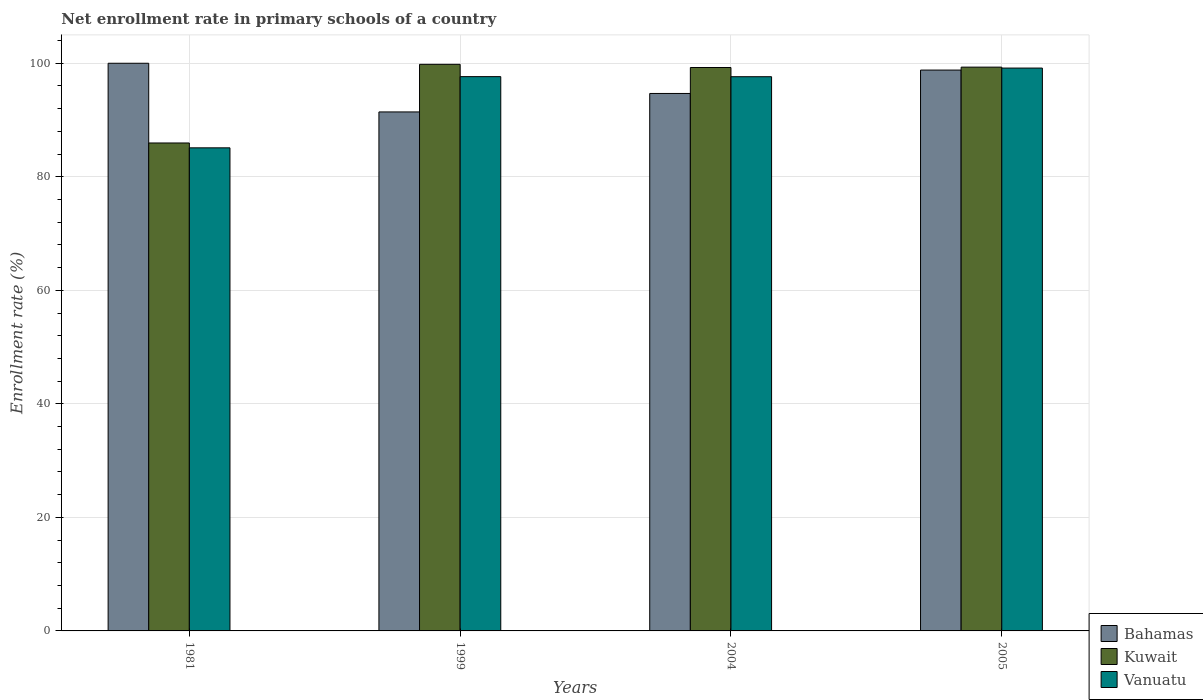How many groups of bars are there?
Provide a short and direct response. 4. Are the number of bars per tick equal to the number of legend labels?
Your answer should be very brief. Yes. Are the number of bars on each tick of the X-axis equal?
Your answer should be compact. Yes. What is the enrollment rate in primary schools in Bahamas in 1999?
Keep it short and to the point. 91.43. Across all years, what is the maximum enrollment rate in primary schools in Bahamas?
Provide a short and direct response. 100. Across all years, what is the minimum enrollment rate in primary schools in Bahamas?
Make the answer very short. 91.43. In which year was the enrollment rate in primary schools in Vanuatu minimum?
Your answer should be compact. 1981. What is the total enrollment rate in primary schools in Vanuatu in the graph?
Your response must be concise. 379.52. What is the difference between the enrollment rate in primary schools in Kuwait in 1999 and that in 2005?
Your answer should be compact. 0.49. What is the difference between the enrollment rate in primary schools in Bahamas in 1981 and the enrollment rate in primary schools in Vanuatu in 2004?
Your response must be concise. 2.37. What is the average enrollment rate in primary schools in Bahamas per year?
Your response must be concise. 96.23. In the year 2004, what is the difference between the enrollment rate in primary schools in Vanuatu and enrollment rate in primary schools in Bahamas?
Your answer should be very brief. 2.95. What is the ratio of the enrollment rate in primary schools in Kuwait in 1999 to that in 2004?
Your answer should be compact. 1.01. Is the enrollment rate in primary schools in Kuwait in 1981 less than that in 2005?
Keep it short and to the point. Yes. Is the difference between the enrollment rate in primary schools in Vanuatu in 1999 and 2005 greater than the difference between the enrollment rate in primary schools in Bahamas in 1999 and 2005?
Make the answer very short. Yes. What is the difference between the highest and the second highest enrollment rate in primary schools in Vanuatu?
Make the answer very short. 1.51. What is the difference between the highest and the lowest enrollment rate in primary schools in Bahamas?
Provide a succinct answer. 8.57. Is the sum of the enrollment rate in primary schools in Kuwait in 1999 and 2005 greater than the maximum enrollment rate in primary schools in Vanuatu across all years?
Provide a short and direct response. Yes. What does the 1st bar from the left in 1999 represents?
Offer a very short reply. Bahamas. What does the 3rd bar from the right in 2005 represents?
Provide a succinct answer. Bahamas. Is it the case that in every year, the sum of the enrollment rate in primary schools in Kuwait and enrollment rate in primary schools in Bahamas is greater than the enrollment rate in primary schools in Vanuatu?
Give a very brief answer. Yes. How many bars are there?
Provide a short and direct response. 12. Are all the bars in the graph horizontal?
Make the answer very short. No. What is the difference between two consecutive major ticks on the Y-axis?
Keep it short and to the point. 20. Are the values on the major ticks of Y-axis written in scientific E-notation?
Give a very brief answer. No. How many legend labels are there?
Give a very brief answer. 3. What is the title of the graph?
Your response must be concise. Net enrollment rate in primary schools of a country. Does "Bangladesh" appear as one of the legend labels in the graph?
Your answer should be very brief. No. What is the label or title of the Y-axis?
Give a very brief answer. Enrollment rate (%). What is the Enrollment rate (%) in Kuwait in 1981?
Offer a terse response. 85.96. What is the Enrollment rate (%) of Vanuatu in 1981?
Give a very brief answer. 85.1. What is the Enrollment rate (%) in Bahamas in 1999?
Your answer should be compact. 91.43. What is the Enrollment rate (%) in Kuwait in 1999?
Provide a succinct answer. 99.81. What is the Enrollment rate (%) in Vanuatu in 1999?
Your answer should be compact. 97.64. What is the Enrollment rate (%) of Bahamas in 2004?
Your response must be concise. 94.68. What is the Enrollment rate (%) of Kuwait in 2004?
Make the answer very short. 99.25. What is the Enrollment rate (%) of Vanuatu in 2004?
Give a very brief answer. 97.63. What is the Enrollment rate (%) of Bahamas in 2005?
Make the answer very short. 98.8. What is the Enrollment rate (%) of Kuwait in 2005?
Provide a short and direct response. 99.32. What is the Enrollment rate (%) of Vanuatu in 2005?
Give a very brief answer. 99.15. Across all years, what is the maximum Enrollment rate (%) of Bahamas?
Your answer should be compact. 100. Across all years, what is the maximum Enrollment rate (%) in Kuwait?
Your answer should be compact. 99.81. Across all years, what is the maximum Enrollment rate (%) in Vanuatu?
Offer a terse response. 99.15. Across all years, what is the minimum Enrollment rate (%) in Bahamas?
Provide a short and direct response. 91.43. Across all years, what is the minimum Enrollment rate (%) in Kuwait?
Offer a terse response. 85.96. Across all years, what is the minimum Enrollment rate (%) in Vanuatu?
Your answer should be very brief. 85.1. What is the total Enrollment rate (%) of Bahamas in the graph?
Your answer should be compact. 384.91. What is the total Enrollment rate (%) in Kuwait in the graph?
Give a very brief answer. 384.33. What is the total Enrollment rate (%) of Vanuatu in the graph?
Keep it short and to the point. 379.52. What is the difference between the Enrollment rate (%) in Bahamas in 1981 and that in 1999?
Your answer should be compact. 8.57. What is the difference between the Enrollment rate (%) in Kuwait in 1981 and that in 1999?
Make the answer very short. -13.85. What is the difference between the Enrollment rate (%) of Vanuatu in 1981 and that in 1999?
Your answer should be very brief. -12.54. What is the difference between the Enrollment rate (%) of Bahamas in 1981 and that in 2004?
Your answer should be compact. 5.32. What is the difference between the Enrollment rate (%) of Kuwait in 1981 and that in 2004?
Give a very brief answer. -13.3. What is the difference between the Enrollment rate (%) of Vanuatu in 1981 and that in 2004?
Give a very brief answer. -12.53. What is the difference between the Enrollment rate (%) of Bahamas in 1981 and that in 2005?
Give a very brief answer. 1.2. What is the difference between the Enrollment rate (%) of Kuwait in 1981 and that in 2005?
Offer a very short reply. -13.36. What is the difference between the Enrollment rate (%) of Vanuatu in 1981 and that in 2005?
Your response must be concise. -14.05. What is the difference between the Enrollment rate (%) of Bahamas in 1999 and that in 2004?
Your response must be concise. -3.25. What is the difference between the Enrollment rate (%) of Kuwait in 1999 and that in 2004?
Your answer should be very brief. 0.56. What is the difference between the Enrollment rate (%) of Vanuatu in 1999 and that in 2004?
Keep it short and to the point. 0.01. What is the difference between the Enrollment rate (%) in Bahamas in 1999 and that in 2005?
Your response must be concise. -7.38. What is the difference between the Enrollment rate (%) in Kuwait in 1999 and that in 2005?
Offer a terse response. 0.49. What is the difference between the Enrollment rate (%) of Vanuatu in 1999 and that in 2005?
Offer a terse response. -1.51. What is the difference between the Enrollment rate (%) of Bahamas in 2004 and that in 2005?
Make the answer very short. -4.12. What is the difference between the Enrollment rate (%) in Kuwait in 2004 and that in 2005?
Offer a very short reply. -0.07. What is the difference between the Enrollment rate (%) in Vanuatu in 2004 and that in 2005?
Provide a succinct answer. -1.52. What is the difference between the Enrollment rate (%) of Bahamas in 1981 and the Enrollment rate (%) of Kuwait in 1999?
Offer a very short reply. 0.19. What is the difference between the Enrollment rate (%) in Bahamas in 1981 and the Enrollment rate (%) in Vanuatu in 1999?
Provide a succinct answer. 2.36. What is the difference between the Enrollment rate (%) of Kuwait in 1981 and the Enrollment rate (%) of Vanuatu in 1999?
Provide a short and direct response. -11.69. What is the difference between the Enrollment rate (%) of Bahamas in 1981 and the Enrollment rate (%) of Kuwait in 2004?
Keep it short and to the point. 0.75. What is the difference between the Enrollment rate (%) of Bahamas in 1981 and the Enrollment rate (%) of Vanuatu in 2004?
Provide a short and direct response. 2.37. What is the difference between the Enrollment rate (%) of Kuwait in 1981 and the Enrollment rate (%) of Vanuatu in 2004?
Your answer should be very brief. -11.67. What is the difference between the Enrollment rate (%) of Bahamas in 1981 and the Enrollment rate (%) of Kuwait in 2005?
Your answer should be very brief. 0.68. What is the difference between the Enrollment rate (%) of Bahamas in 1981 and the Enrollment rate (%) of Vanuatu in 2005?
Your response must be concise. 0.85. What is the difference between the Enrollment rate (%) in Kuwait in 1981 and the Enrollment rate (%) in Vanuatu in 2005?
Offer a very short reply. -13.2. What is the difference between the Enrollment rate (%) of Bahamas in 1999 and the Enrollment rate (%) of Kuwait in 2004?
Provide a succinct answer. -7.83. What is the difference between the Enrollment rate (%) of Bahamas in 1999 and the Enrollment rate (%) of Vanuatu in 2004?
Provide a succinct answer. -6.2. What is the difference between the Enrollment rate (%) of Kuwait in 1999 and the Enrollment rate (%) of Vanuatu in 2004?
Provide a short and direct response. 2.18. What is the difference between the Enrollment rate (%) in Bahamas in 1999 and the Enrollment rate (%) in Kuwait in 2005?
Your response must be concise. -7.89. What is the difference between the Enrollment rate (%) in Bahamas in 1999 and the Enrollment rate (%) in Vanuatu in 2005?
Offer a very short reply. -7.73. What is the difference between the Enrollment rate (%) of Kuwait in 1999 and the Enrollment rate (%) of Vanuatu in 2005?
Your answer should be compact. 0.66. What is the difference between the Enrollment rate (%) of Bahamas in 2004 and the Enrollment rate (%) of Kuwait in 2005?
Your answer should be compact. -4.64. What is the difference between the Enrollment rate (%) in Bahamas in 2004 and the Enrollment rate (%) in Vanuatu in 2005?
Ensure brevity in your answer.  -4.47. What is the difference between the Enrollment rate (%) in Kuwait in 2004 and the Enrollment rate (%) in Vanuatu in 2005?
Offer a very short reply. 0.1. What is the average Enrollment rate (%) of Bahamas per year?
Provide a succinct answer. 96.23. What is the average Enrollment rate (%) in Kuwait per year?
Make the answer very short. 96.08. What is the average Enrollment rate (%) of Vanuatu per year?
Your response must be concise. 94.88. In the year 1981, what is the difference between the Enrollment rate (%) of Bahamas and Enrollment rate (%) of Kuwait?
Your response must be concise. 14.04. In the year 1981, what is the difference between the Enrollment rate (%) in Bahamas and Enrollment rate (%) in Vanuatu?
Ensure brevity in your answer.  14.9. In the year 1981, what is the difference between the Enrollment rate (%) of Kuwait and Enrollment rate (%) of Vanuatu?
Give a very brief answer. 0.86. In the year 1999, what is the difference between the Enrollment rate (%) of Bahamas and Enrollment rate (%) of Kuwait?
Keep it short and to the point. -8.38. In the year 1999, what is the difference between the Enrollment rate (%) of Bahamas and Enrollment rate (%) of Vanuatu?
Your answer should be very brief. -6.22. In the year 1999, what is the difference between the Enrollment rate (%) of Kuwait and Enrollment rate (%) of Vanuatu?
Keep it short and to the point. 2.17. In the year 2004, what is the difference between the Enrollment rate (%) of Bahamas and Enrollment rate (%) of Kuwait?
Make the answer very short. -4.57. In the year 2004, what is the difference between the Enrollment rate (%) of Bahamas and Enrollment rate (%) of Vanuatu?
Your response must be concise. -2.95. In the year 2004, what is the difference between the Enrollment rate (%) of Kuwait and Enrollment rate (%) of Vanuatu?
Give a very brief answer. 1.62. In the year 2005, what is the difference between the Enrollment rate (%) in Bahamas and Enrollment rate (%) in Kuwait?
Provide a short and direct response. -0.52. In the year 2005, what is the difference between the Enrollment rate (%) of Bahamas and Enrollment rate (%) of Vanuatu?
Keep it short and to the point. -0.35. In the year 2005, what is the difference between the Enrollment rate (%) of Kuwait and Enrollment rate (%) of Vanuatu?
Offer a terse response. 0.17. What is the ratio of the Enrollment rate (%) of Bahamas in 1981 to that in 1999?
Your response must be concise. 1.09. What is the ratio of the Enrollment rate (%) in Kuwait in 1981 to that in 1999?
Make the answer very short. 0.86. What is the ratio of the Enrollment rate (%) in Vanuatu in 1981 to that in 1999?
Offer a very short reply. 0.87. What is the ratio of the Enrollment rate (%) of Bahamas in 1981 to that in 2004?
Provide a succinct answer. 1.06. What is the ratio of the Enrollment rate (%) in Kuwait in 1981 to that in 2004?
Give a very brief answer. 0.87. What is the ratio of the Enrollment rate (%) of Vanuatu in 1981 to that in 2004?
Provide a short and direct response. 0.87. What is the ratio of the Enrollment rate (%) of Bahamas in 1981 to that in 2005?
Keep it short and to the point. 1.01. What is the ratio of the Enrollment rate (%) of Kuwait in 1981 to that in 2005?
Offer a very short reply. 0.87. What is the ratio of the Enrollment rate (%) of Vanuatu in 1981 to that in 2005?
Make the answer very short. 0.86. What is the ratio of the Enrollment rate (%) in Bahamas in 1999 to that in 2004?
Your answer should be compact. 0.97. What is the ratio of the Enrollment rate (%) in Kuwait in 1999 to that in 2004?
Provide a succinct answer. 1.01. What is the ratio of the Enrollment rate (%) in Bahamas in 1999 to that in 2005?
Offer a very short reply. 0.93. What is the ratio of the Enrollment rate (%) of Kuwait in 1999 to that in 2005?
Ensure brevity in your answer.  1. What is the ratio of the Enrollment rate (%) of Vanuatu in 2004 to that in 2005?
Keep it short and to the point. 0.98. What is the difference between the highest and the second highest Enrollment rate (%) of Bahamas?
Offer a terse response. 1.2. What is the difference between the highest and the second highest Enrollment rate (%) in Kuwait?
Make the answer very short. 0.49. What is the difference between the highest and the second highest Enrollment rate (%) of Vanuatu?
Ensure brevity in your answer.  1.51. What is the difference between the highest and the lowest Enrollment rate (%) of Bahamas?
Your answer should be compact. 8.57. What is the difference between the highest and the lowest Enrollment rate (%) of Kuwait?
Offer a very short reply. 13.85. What is the difference between the highest and the lowest Enrollment rate (%) in Vanuatu?
Your answer should be compact. 14.05. 